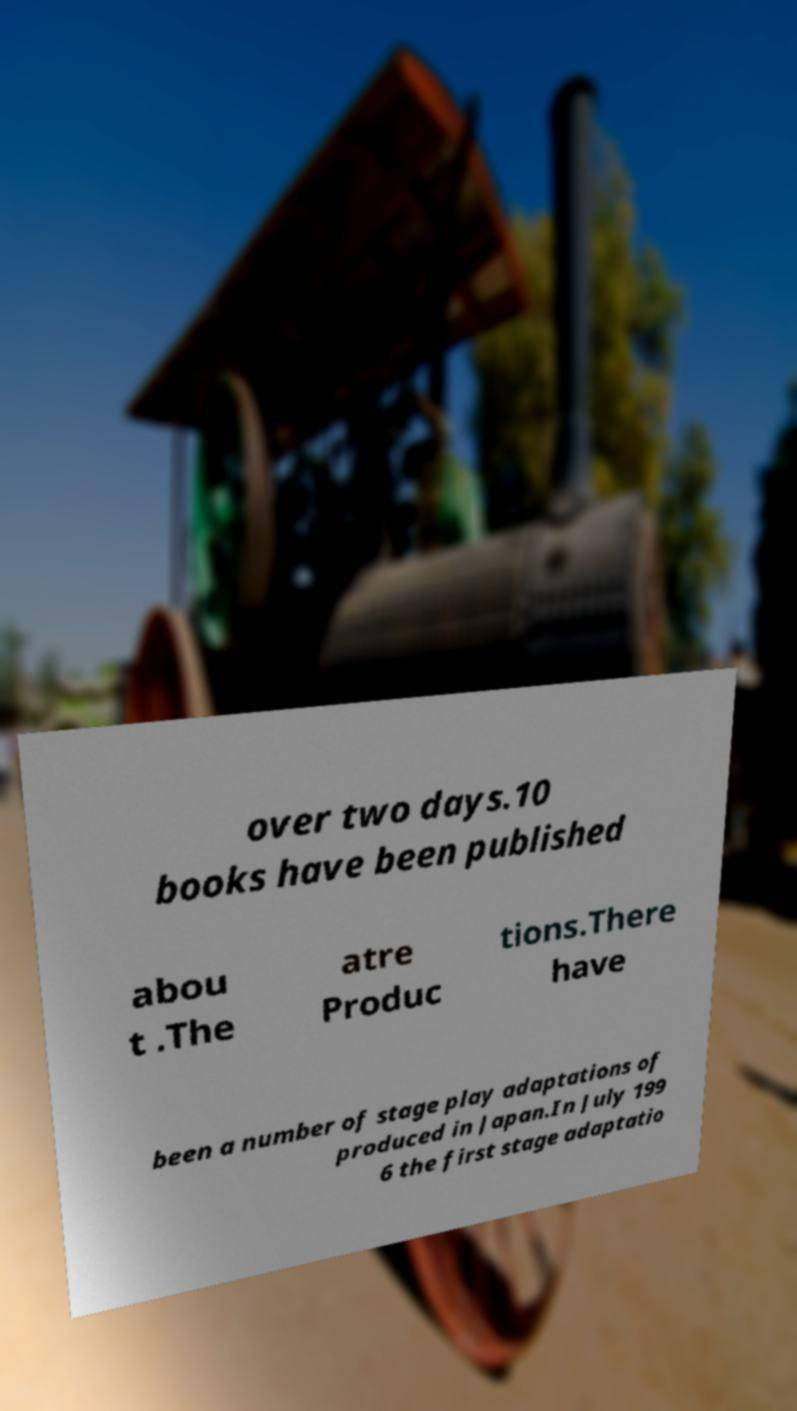I need the written content from this picture converted into text. Can you do that? over two days.10 books have been published abou t .The atre Produc tions.There have been a number of stage play adaptations of produced in Japan.In July 199 6 the first stage adaptatio 